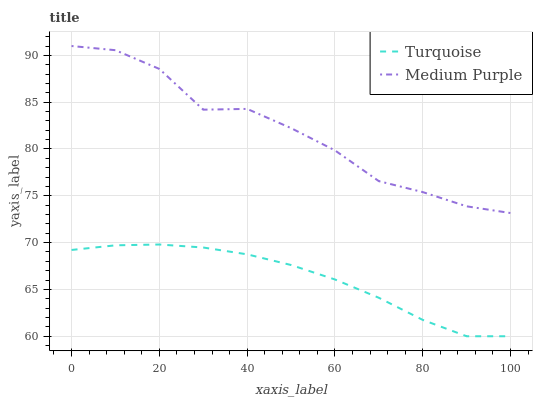Does Turquoise have the minimum area under the curve?
Answer yes or no. Yes. Does Medium Purple have the maximum area under the curve?
Answer yes or no. Yes. Does Turquoise have the maximum area under the curve?
Answer yes or no. No. Is Turquoise the smoothest?
Answer yes or no. Yes. Is Medium Purple the roughest?
Answer yes or no. Yes. Is Turquoise the roughest?
Answer yes or no. No. Does Turquoise have the lowest value?
Answer yes or no. Yes. Does Medium Purple have the highest value?
Answer yes or no. Yes. Does Turquoise have the highest value?
Answer yes or no. No. Is Turquoise less than Medium Purple?
Answer yes or no. Yes. Is Medium Purple greater than Turquoise?
Answer yes or no. Yes. Does Turquoise intersect Medium Purple?
Answer yes or no. No. 